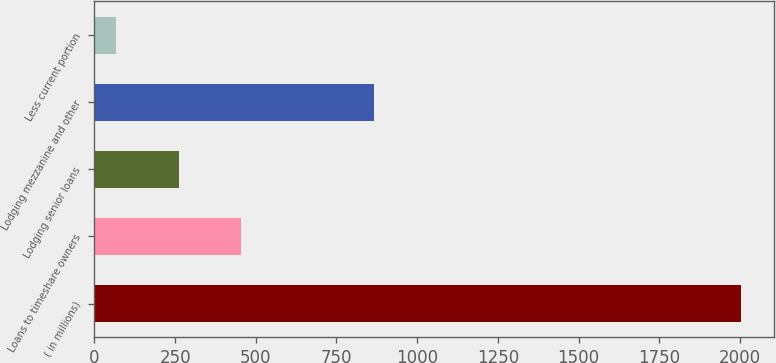<chart> <loc_0><loc_0><loc_500><loc_500><bar_chart><fcel>( in millions)<fcel>Loans to timeshare owners<fcel>Lodging senior loans<fcel>Lodging mezzanine and other<fcel>Less current portion<nl><fcel>2004<fcel>455.2<fcel>261.6<fcel>867<fcel>68<nl></chart> 